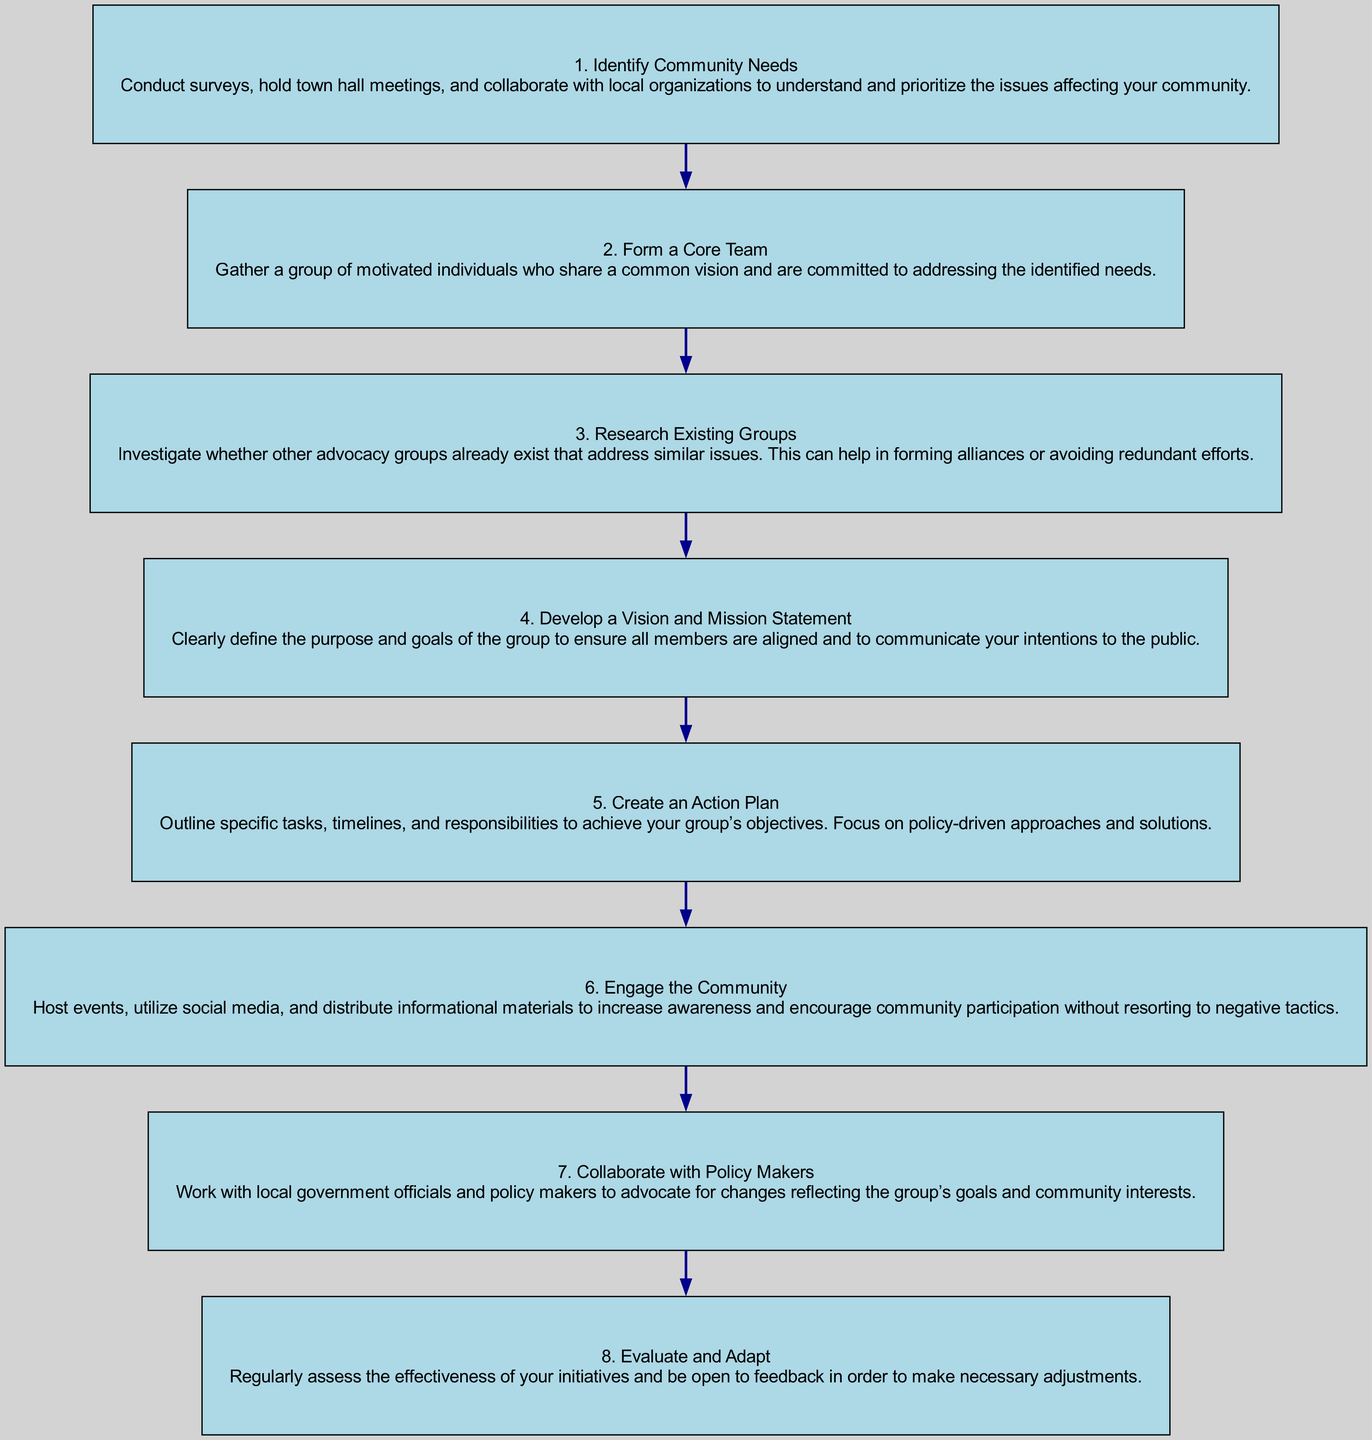What is the first step in starting a community advocacy group? The first step in the diagram is labeled as "1. Identify Community Needs" which suggests conducting surveys, holding town hall meetings, and collaborating with local organizations to understand and prioritize community issues.
Answer: Identify Community Needs How many total steps are outlined in the flow chart? By counting the numbered steps in the diagram, there are eight distinct steps outlined for starting a community advocacy group.
Answer: Eight What does the second step involve? The second step is "2. Form a Core Team" which involves gathering motivated individuals who share a common vision and are committed to addressing identified needs.
Answer: Form a Core Team What is the relationship between the "Create an Action Plan" step and the "Collaborate with Policy Makers" step? "Create an Action Plan" (step 5) precedes "Collaborate with Policy Makers" (step 7) indicating that before collaborating with policymakers, it is essential to outline specific tasks and responsibilities.
Answer: Sequential relationship Which step focuses on engaging with the community? The step that focuses on engaging with the community is "6. Engage the Community," which emphasizes hosting events and utilizing social media to encourage participation.
Answer: Engage the Community What is the purpose of the "Evaluate and Adapt" step? The purpose of "8. Evaluate and Adapt" is to regularly assess the effectiveness of initiatives and be open to feedback for necessary adjustments, ensuring the group remains effective in its advocacy efforts.
Answer: Regularly assess effectiveness Which step suggests avoiding negative tactics? "6. Engage the Community" specifically mentions not resorting to negative tactics while increasing awareness and encouraging community participation.
Answer: Engage the Community Which steps are directly related to the community's needs? "1. Identify Community Needs" focuses on understanding community issues, and "4. Develop a Vision and Mission Statement" captures the purpose and goals based on those needs.
Answer: Steps 1 and 4 What is the outcome of collaborating with policy makers? The outcome would be advocating for changes that reflect the group's goals and community interests as outlined in step 7, "Collaborate with Policy Makers."
Answer: Advocate for changes 